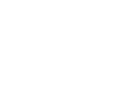<formula> <loc_0><loc_0><loc_500><loc_500>\begin{smallmatrix} 2 & 1 & 0 & 1 & 0 \\ 1 & 3 & 1 & 0 & 1 \\ 0 & 1 & 3 & 1 & 1 \\ 1 & 0 & 1 & 3 & 1 \\ 0 & 1 & 1 & 1 & 3 \end{smallmatrix}</formula> 